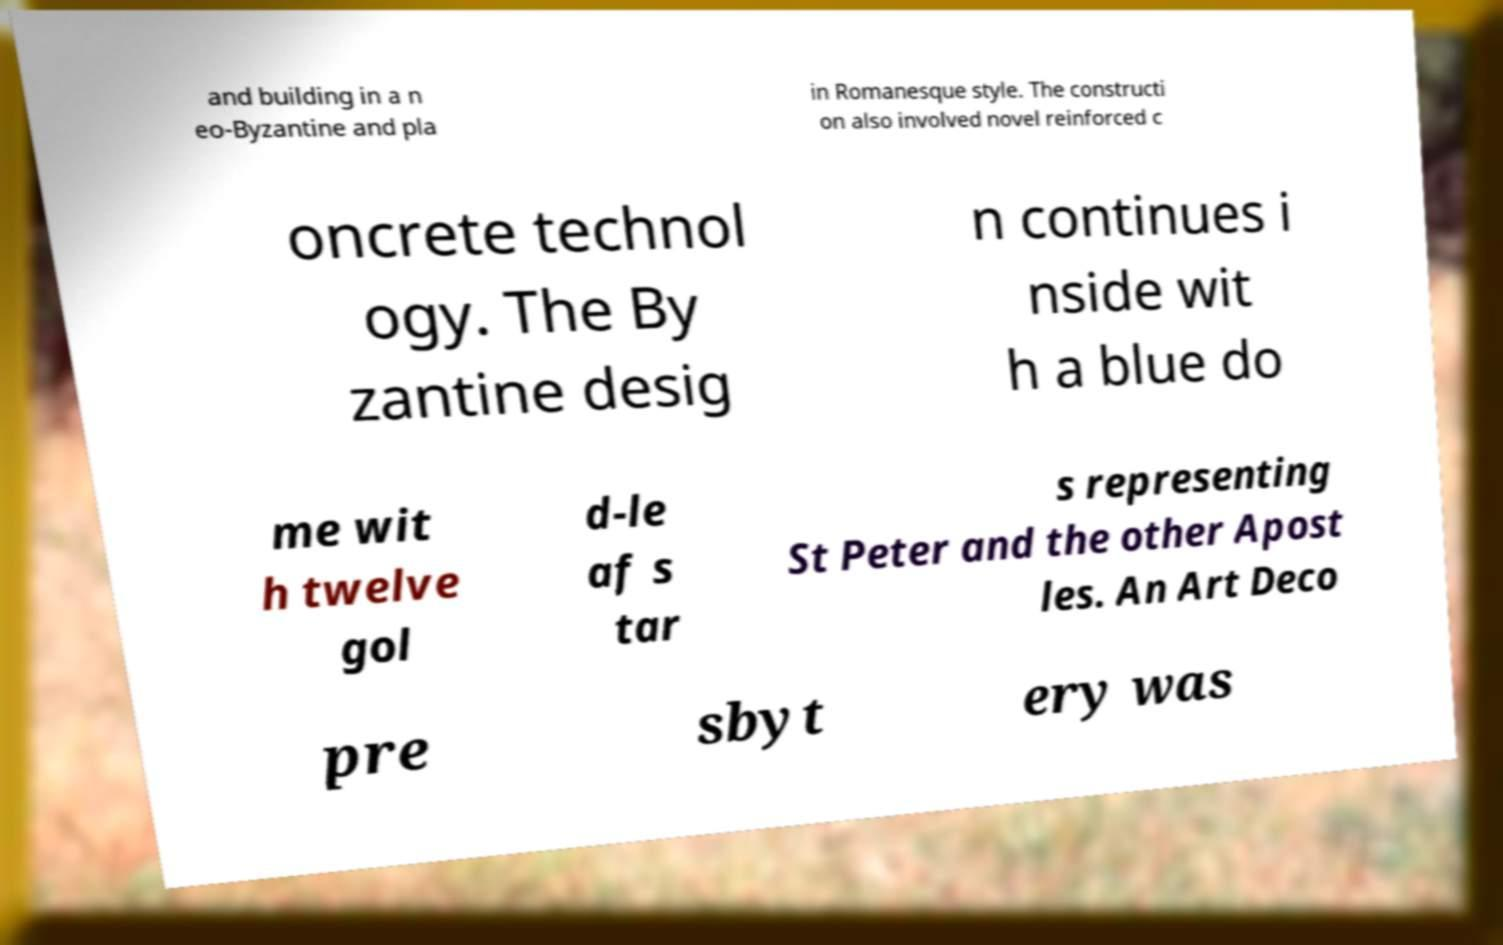What messages or text are displayed in this image? I need them in a readable, typed format. and building in a n eo-Byzantine and pla in Romanesque style. The constructi on also involved novel reinforced c oncrete technol ogy. The By zantine desig n continues i nside wit h a blue do me wit h twelve gol d-le af s tar s representing St Peter and the other Apost les. An Art Deco pre sbyt ery was 